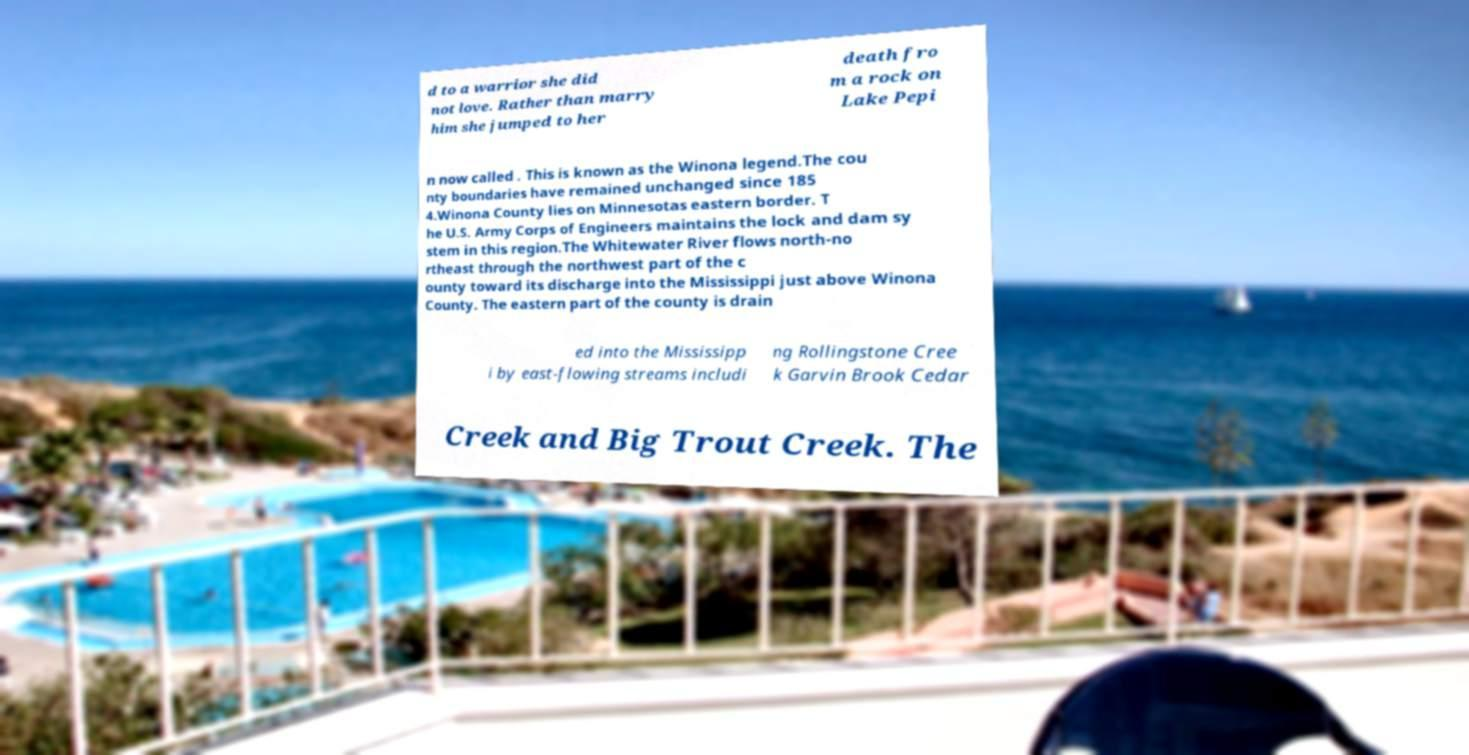Could you extract and type out the text from this image? d to a warrior she did not love. Rather than marry him she jumped to her death fro m a rock on Lake Pepi n now called . This is known as the Winona legend.The cou nty boundaries have remained unchanged since 185 4.Winona County lies on Minnesotas eastern border. T he U.S. Army Corps of Engineers maintains the lock and dam sy stem in this region.The Whitewater River flows north-no rtheast through the northwest part of the c ounty toward its discharge into the Mississippi just above Winona County. The eastern part of the county is drain ed into the Mississipp i by east-flowing streams includi ng Rollingstone Cree k Garvin Brook Cedar Creek and Big Trout Creek. The 